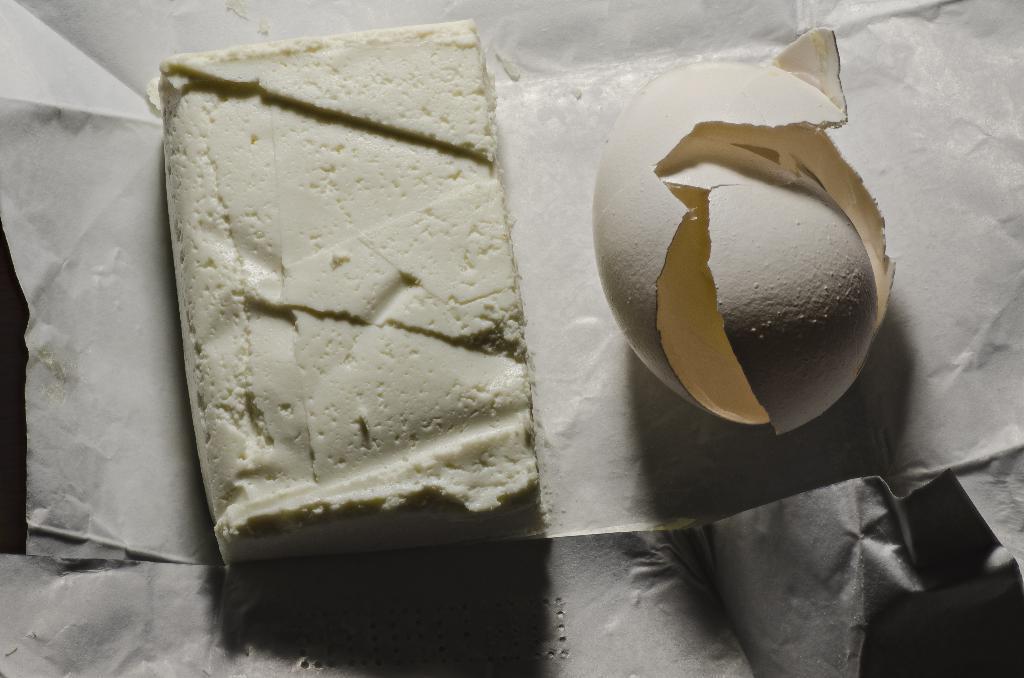In one or two sentences, can you explain what this image depicts? In this image, we can see egg shells and food item on the white paper. 